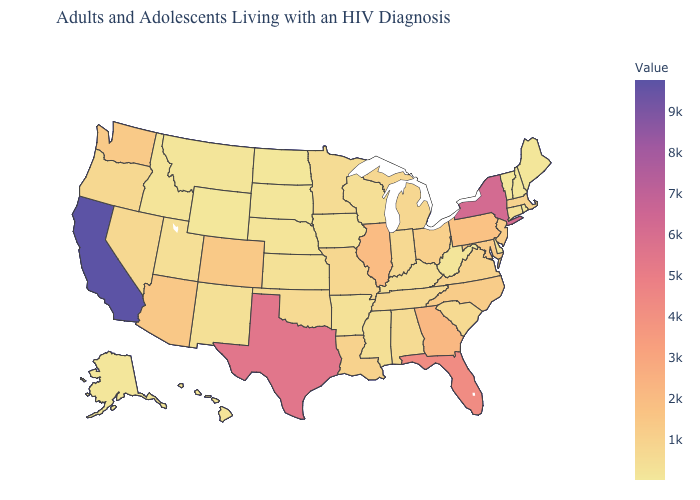Which states have the highest value in the USA?
Give a very brief answer. California. Among the states that border South Dakota , does Minnesota have the highest value?
Answer briefly. Yes. Does Colorado have the highest value in the USA?
Quick response, please. No. Among the states that border West Virginia , which have the lowest value?
Quick response, please. Kentucky. Is the legend a continuous bar?
Quick response, please. Yes. Among the states that border Colorado , which have the highest value?
Be succinct. Arizona. Among the states that border New Jersey , which have the lowest value?
Write a very short answer. Delaware. 